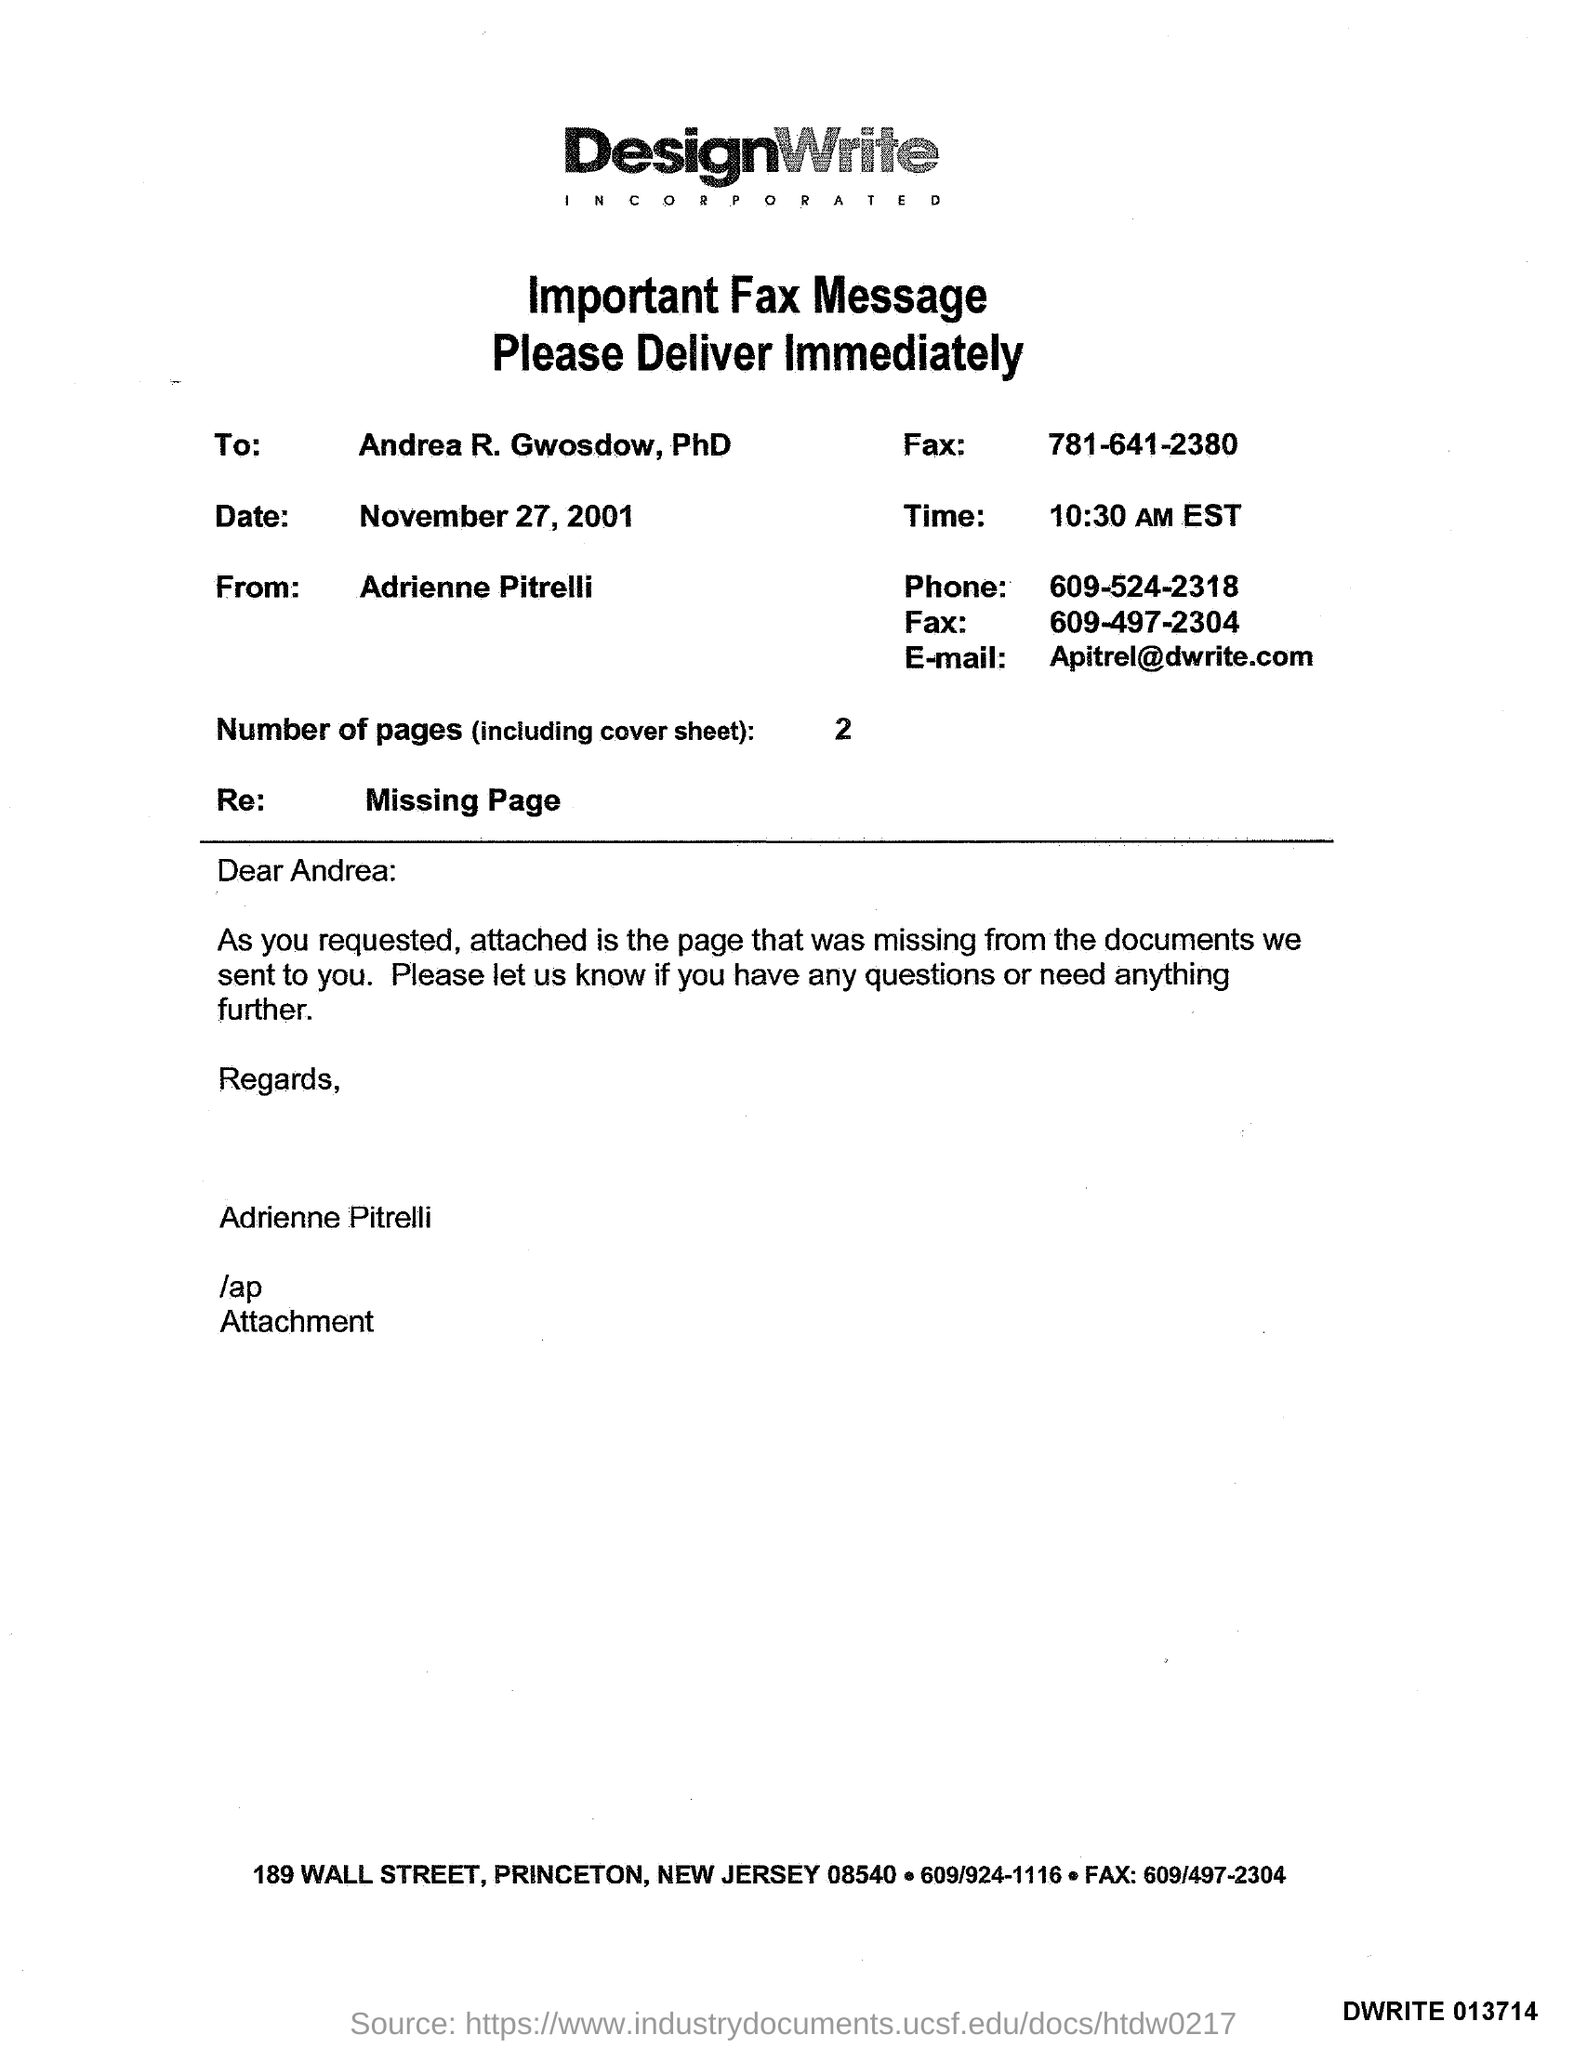Point out several critical features in this image. The memorandum is addressed to Andrea R. Gwosdow, PhD. What is the title of the document? DesignWrite Incorporated... The sentence "What is the Sender Phone Number ? 609-524-2318..." is a question asking for information about the phone number of the sender. The Memorandum is from Adrienne Pitrelli. The date mentioned in the document is November 27, 2001. 